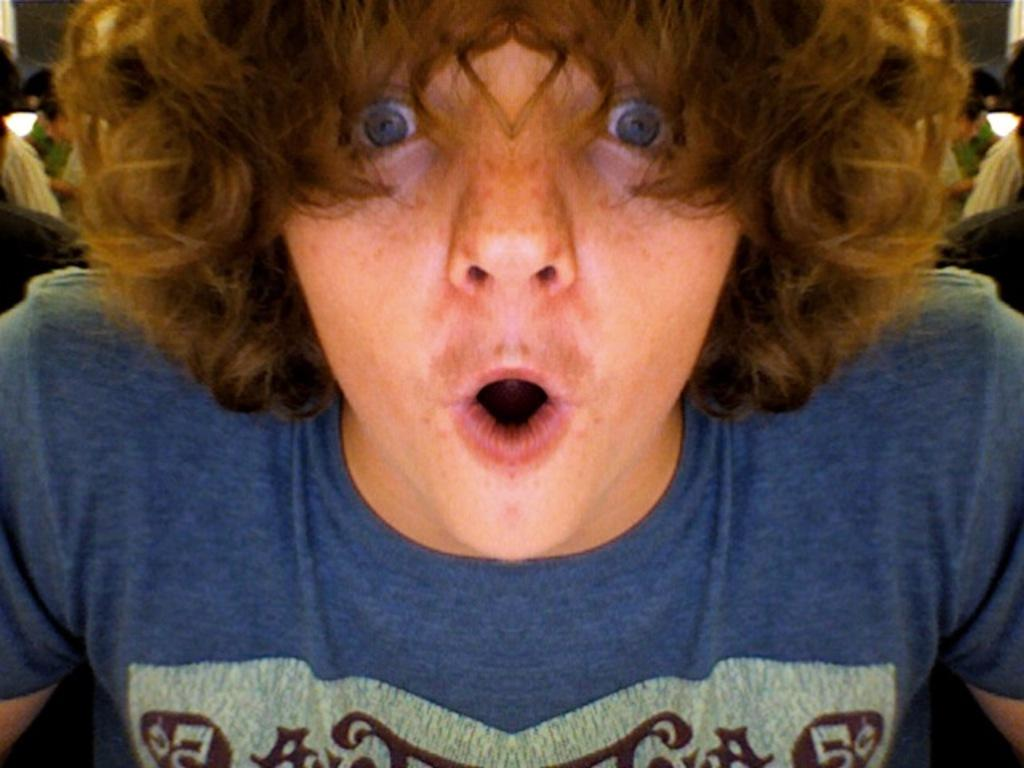What is the main subject of the image? There is a man in the image. What is the man wearing in the image? The man is wearing a blue T-shirt. What is the man doing in the image? The man appears to be shouting. How many ghosts can be seen in the image? There are no ghosts present in the image. 